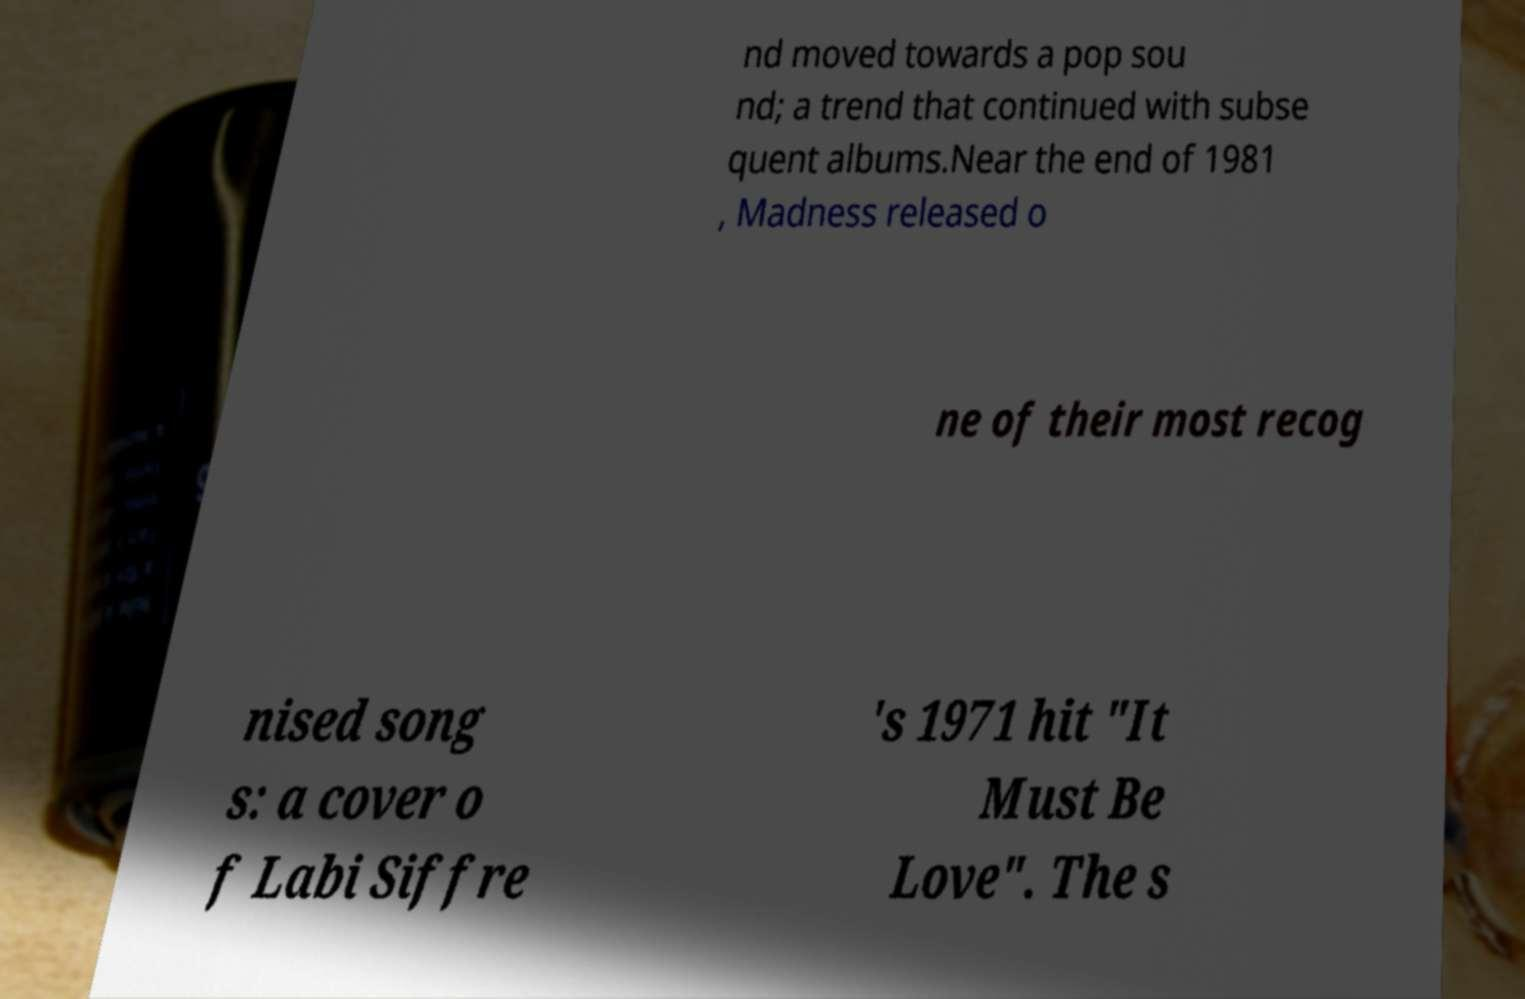I need the written content from this picture converted into text. Can you do that? nd moved towards a pop sou nd; a trend that continued with subse quent albums.Near the end of 1981 , Madness released o ne of their most recog nised song s: a cover o f Labi Siffre 's 1971 hit "It Must Be Love". The s 